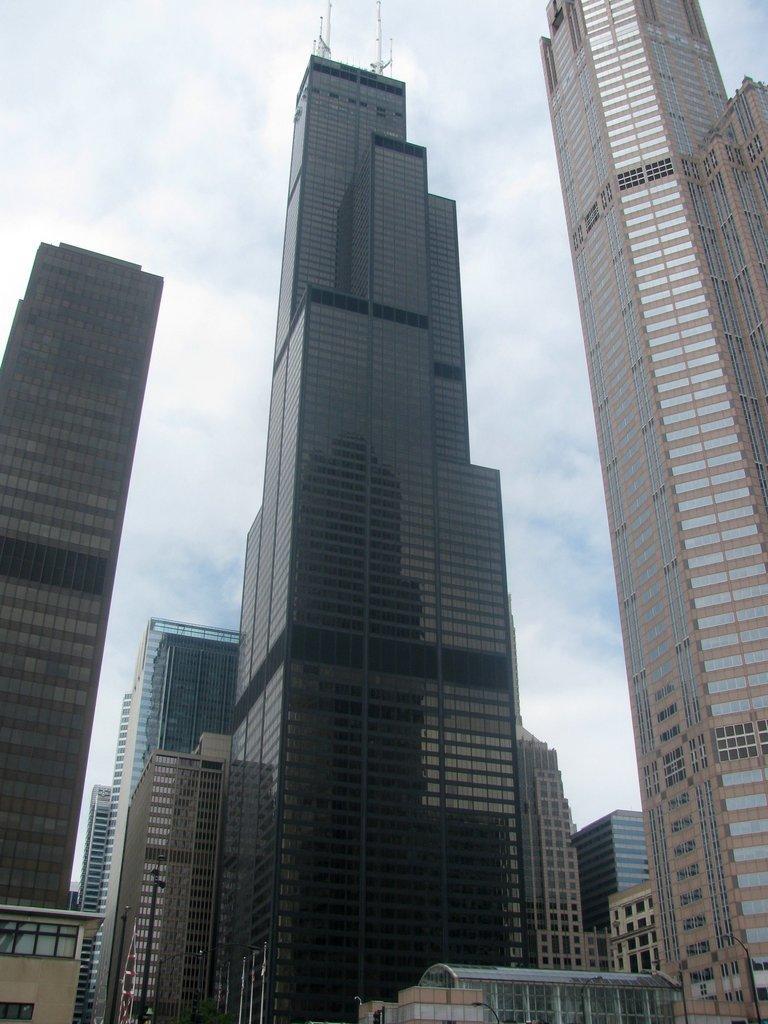Please provide a concise description of this image. In this image, we can see buildings and in the background, there are clouds in the sky. 